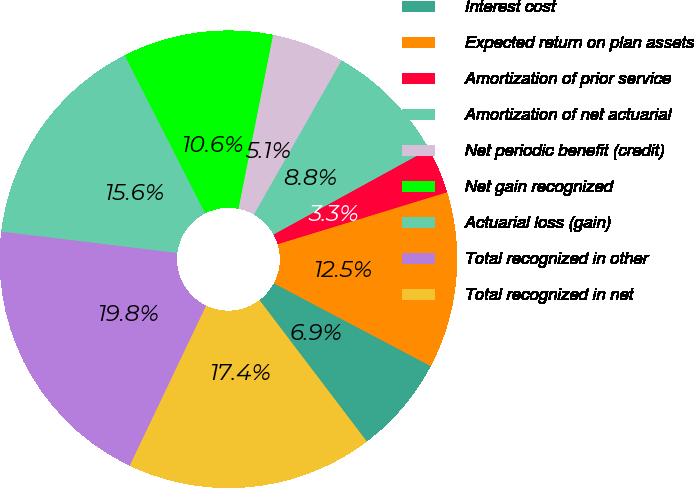Convert chart. <chart><loc_0><loc_0><loc_500><loc_500><pie_chart><fcel>Interest cost<fcel>Expected return on plan assets<fcel>Amortization of prior service<fcel>Amortization of net actuarial<fcel>Net periodic benefit (credit)<fcel>Net gain recognized<fcel>Actuarial loss (gain)<fcel>Total recognized in other<fcel>Total recognized in net<nl><fcel>6.94%<fcel>12.46%<fcel>3.26%<fcel>8.78%<fcel>5.1%<fcel>10.62%<fcel>15.58%<fcel>19.83%<fcel>17.42%<nl></chart> 